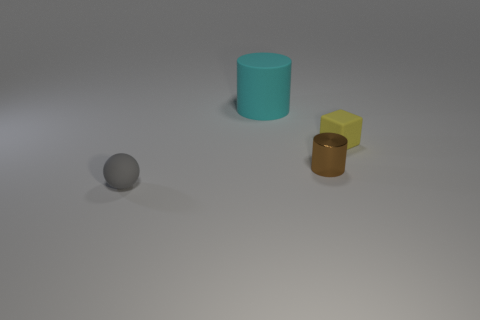Is there anything else that is the same size as the cyan object?
Keep it short and to the point. No. Do the big thing that is behind the small brown object and the small rubber object right of the gray thing have the same shape?
Keep it short and to the point. No. Is there a yellow object made of the same material as the small cylinder?
Your answer should be compact. No. What number of metal things are either cyan objects or small gray things?
Make the answer very short. 0. What shape is the small rubber object that is to the right of the tiny gray rubber ball that is in front of the yellow matte cube?
Offer a very short reply. Cube. Are there fewer large cylinders that are in front of the large rubber object than shiny cubes?
Ensure brevity in your answer.  No. What is the shape of the small brown metal object?
Ensure brevity in your answer.  Cylinder. There is a thing on the right side of the brown shiny cylinder; how big is it?
Offer a very short reply. Small. There is a metallic cylinder that is the same size as the rubber block; what color is it?
Ensure brevity in your answer.  Brown. Is there a metal cylinder that has the same color as the matte ball?
Ensure brevity in your answer.  No. 